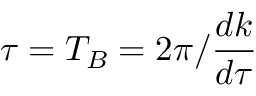Convert formula to latex. <formula><loc_0><loc_0><loc_500><loc_500>\tau = T _ { B } = 2 \pi / \frac { d k } { d \tau }</formula> 